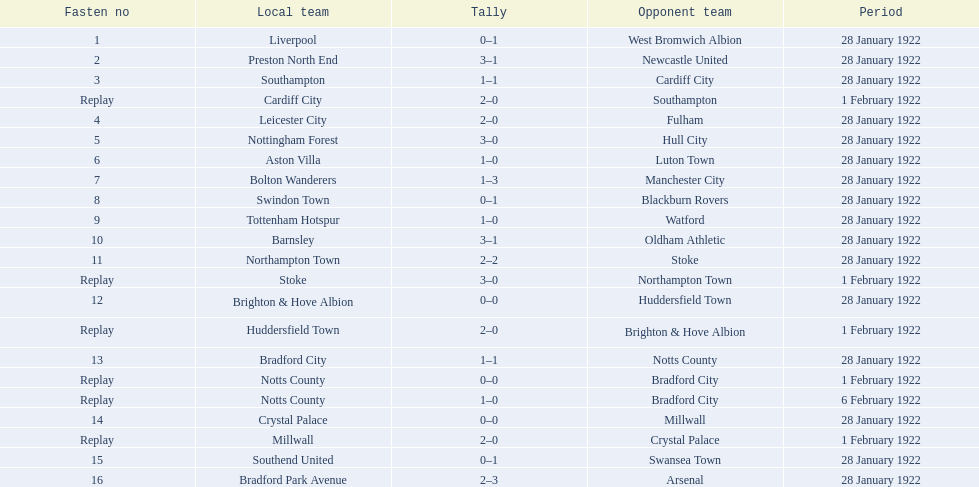Would you be able to parse every entry in this table? {'header': ['Fasten no', 'Local team', 'Tally', 'Opponent team', 'Period'], 'rows': [['1', 'Liverpool', '0–1', 'West Bromwich Albion', '28 January 1922'], ['2', 'Preston North End', '3–1', 'Newcastle United', '28 January 1922'], ['3', 'Southampton', '1–1', 'Cardiff City', '28 January 1922'], ['Replay', 'Cardiff City', '2–0', 'Southampton', '1 February 1922'], ['4', 'Leicester City', '2–0', 'Fulham', '28 January 1922'], ['5', 'Nottingham Forest', '3–0', 'Hull City', '28 January 1922'], ['6', 'Aston Villa', '1–0', 'Luton Town', '28 January 1922'], ['7', 'Bolton Wanderers', '1–3', 'Manchester City', '28 January 1922'], ['8', 'Swindon Town', '0–1', 'Blackburn Rovers', '28 January 1922'], ['9', 'Tottenham Hotspur', '1–0', 'Watford', '28 January 1922'], ['10', 'Barnsley', '3–1', 'Oldham Athletic', '28 January 1922'], ['11', 'Northampton Town', '2–2', 'Stoke', '28 January 1922'], ['Replay', 'Stoke', '3–0', 'Northampton Town', '1 February 1922'], ['12', 'Brighton & Hove Albion', '0–0', 'Huddersfield Town', '28 January 1922'], ['Replay', 'Huddersfield Town', '2–0', 'Brighton & Hove Albion', '1 February 1922'], ['13', 'Bradford City', '1–1', 'Notts County', '28 January 1922'], ['Replay', 'Notts County', '0–0', 'Bradford City', '1 February 1922'], ['Replay', 'Notts County', '1–0', 'Bradford City', '6 February 1922'], ['14', 'Crystal Palace', '0–0', 'Millwall', '28 January 1922'], ['Replay', 'Millwall', '2–0', 'Crystal Palace', '1 February 1922'], ['15', 'Southend United', '0–1', 'Swansea Town', '28 January 1922'], ['16', 'Bradford Park Avenue', '2–3', 'Arsenal', '28 January 1922']]} How many games had no points scored? 3. 